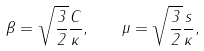<formula> <loc_0><loc_0><loc_500><loc_500>\beta = \sqrt { \frac { 3 } { 2 } } \frac { C } { \kappa } , \quad \mu = \sqrt { \frac { 3 } { 2 } } \frac { s } { \kappa } ,</formula> 